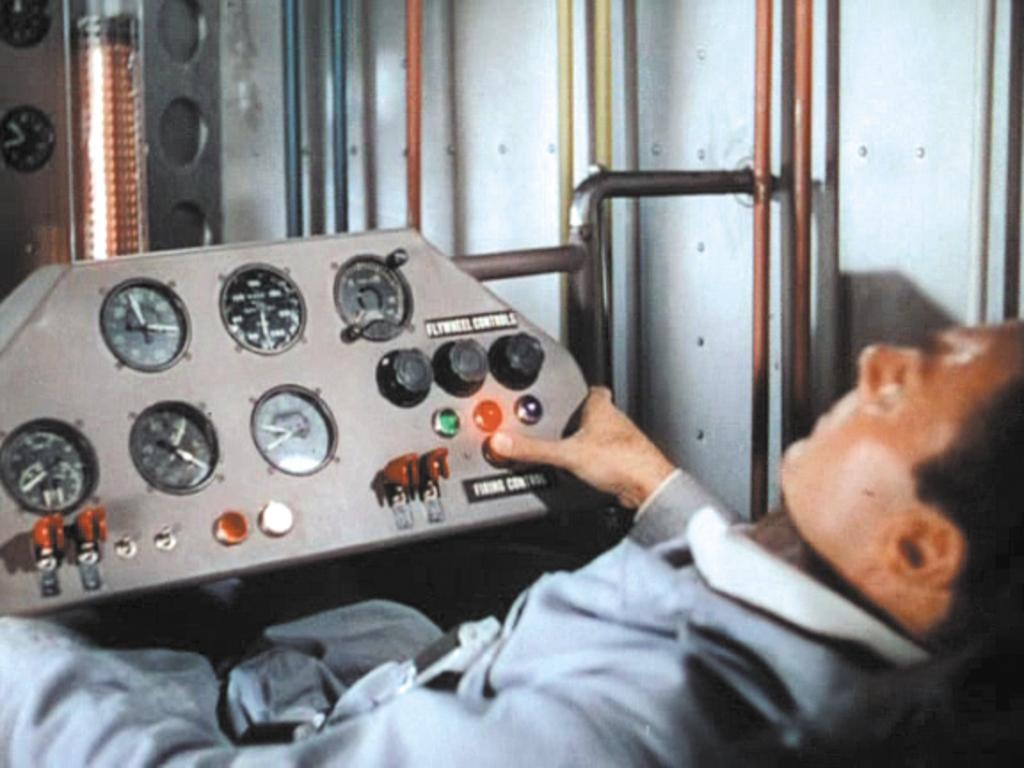Who or what is present in the image? There is a person in the image. What is the person doing in the image? The person is touching the speedometer board. What can be seen in the background of the image? There are walls visible in the image. What else is attached to the walls in the image? There are pipelines attached to the wall in the image. What type of agreement is being signed by the person in the image? There is no indication of a person signing an agreement in the image; the person is touching the speedometer board. Can you see any feathers in the image? There are no feathers present in the image. 